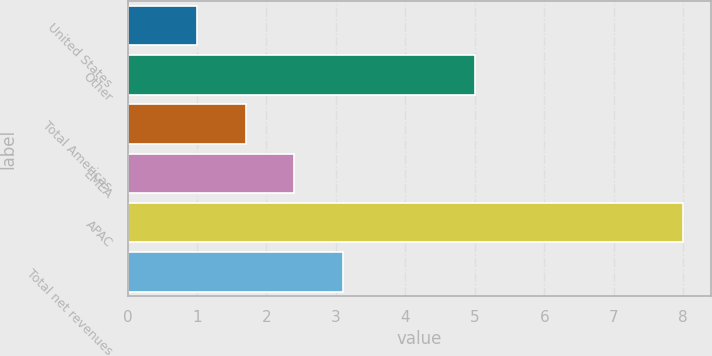<chart> <loc_0><loc_0><loc_500><loc_500><bar_chart><fcel>United States<fcel>Other<fcel>Total Americas<fcel>EMEA<fcel>APAC<fcel>Total net revenues<nl><fcel>1<fcel>5<fcel>1.7<fcel>2.4<fcel>8<fcel>3.1<nl></chart> 